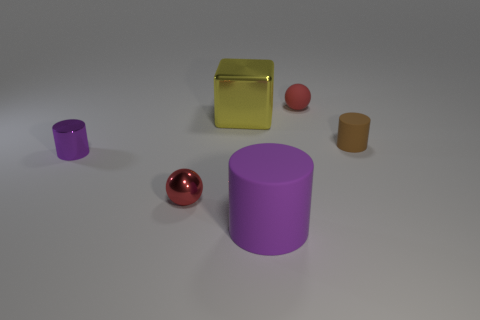Is the large purple rubber object the same shape as the big yellow object?
Your answer should be very brief. No. There is a brown object; is it the same shape as the big object behind the small brown matte object?
Give a very brief answer. No. Are there any objects in front of the small red metallic object?
Your answer should be very brief. Yes. There is a thing that is the same color as the small metallic cylinder; what is it made of?
Offer a very short reply. Rubber. There is a red metal sphere; is its size the same as the rubber cylinder in front of the small brown rubber cylinder?
Make the answer very short. No. Is there a matte object that has the same color as the small metallic cylinder?
Provide a succinct answer. Yes. Are there any metallic things that have the same shape as the big purple rubber object?
Make the answer very short. Yes. There is a metal thing that is both behind the metallic sphere and on the right side of the purple metal object; what shape is it?
Keep it short and to the point. Cube. What number of yellow objects have the same material as the yellow cube?
Offer a very short reply. 0. Is the number of rubber cylinders behind the metallic block less than the number of small brown blocks?
Make the answer very short. No. 